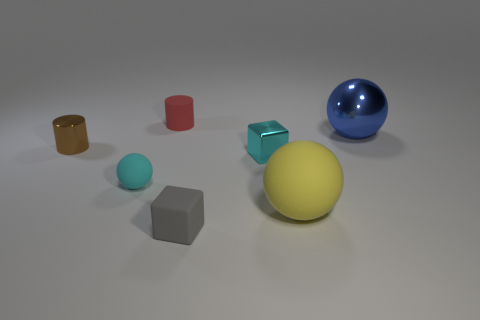Add 2 large blue things. How many objects exist? 9 Subtract all cubes. How many objects are left? 5 Add 5 large shiny objects. How many large shiny objects are left? 6 Add 6 tiny metal cubes. How many tiny metal cubes exist? 7 Subtract 0 purple balls. How many objects are left? 7 Subtract all small rubber spheres. Subtract all big cyan things. How many objects are left? 6 